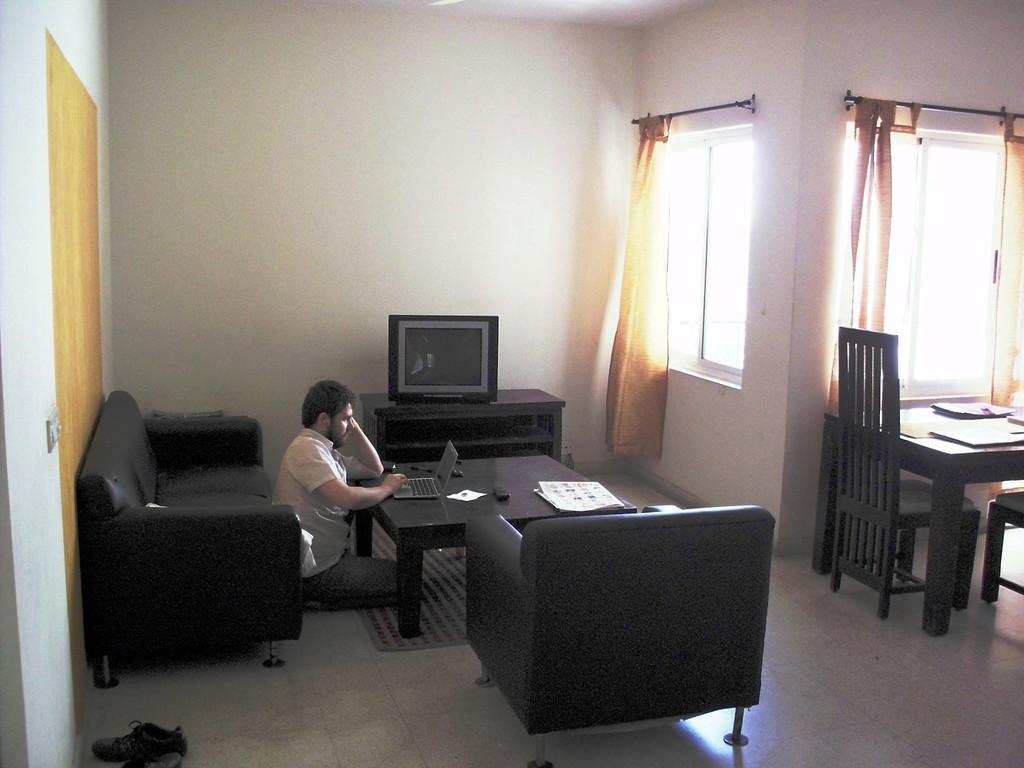Describe this image in one or two sentences. This picture shows an interview of a house and we see a sofa and a chair and we see a man seated and working on the laptop on a table and we see a television and couple of chairs and a table 